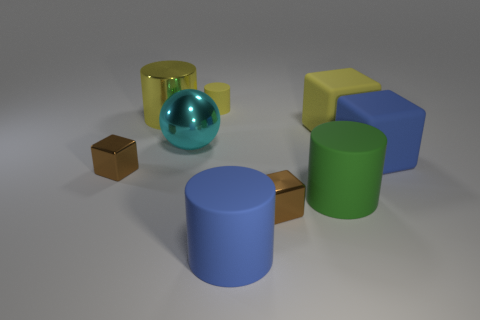Is the number of big blue matte things to the right of the large blue matte cube less than the number of brown metallic cylinders?
Make the answer very short. No. Is the size of the blue matte thing that is left of the yellow matte block the same as the cyan sphere?
Your response must be concise. Yes. What number of yellow matte objects are right of the big green object and behind the big yellow cylinder?
Offer a terse response. 0. There is a brown block to the right of the large cylinder behind the big yellow block; what size is it?
Offer a terse response. Small. Is the number of large cyan metal objects that are in front of the large blue cube less than the number of small yellow cylinders that are in front of the yellow block?
Your answer should be compact. No. There is a metal block that is right of the large cyan ball; does it have the same color as the big rubber object behind the blue block?
Offer a very short reply. No. There is a big thing that is both on the right side of the yellow rubber cylinder and left of the green cylinder; what is its material?
Offer a very short reply. Rubber. Is there a metallic thing?
Make the answer very short. Yes. The small yellow object that is made of the same material as the large green thing is what shape?
Make the answer very short. Cylinder. There is a green rubber object; does it have the same shape as the tiny brown thing that is left of the tiny rubber thing?
Ensure brevity in your answer.  No. 